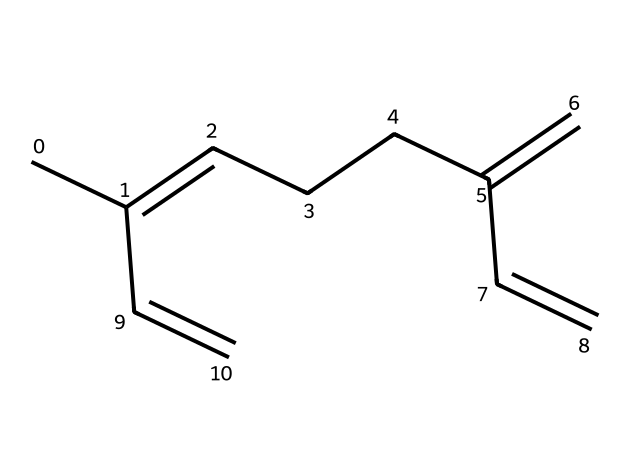What is the name of this compound? The SMILES representation provided corresponds to a specific chemical structure. By analyzing the structure, it can be identified as myrcene, a well-known terpene.
Answer: myrcene How many carbon atoms are in the structure? Counting the carbon atoms in the SMILES notation, there are 10 carbon atoms in total.
Answer: 10 What type of hydrocarbon is myrcene classified as? Given its structure, myrcene can be categorized as a monocyclic alkene with multiple double bonds. Therefore, it fits the description of an unsaturated hydrocarbon.
Answer: unsaturated How many double bonds are present in this molecule? Analyzing the structure, there are three double bonds indicated by the connections in the SMILES representation.
Answer: 3 What kind of scent or flavor might myrcene contribute to medicinal herbs? Myrcene is known for its earthy and musky aroma, typical of many healing herbs that have a relaxing effect.
Answer: earthy Why might myrcene have therapeutic applications in ancestral healing? The structure of myrcene, with its specific arrangement of double bonds, contributes to its biological activities such as anti-inflammatory and sedative properties, making it sought after in traditional medicine.
Answer: anti-inflammatory 